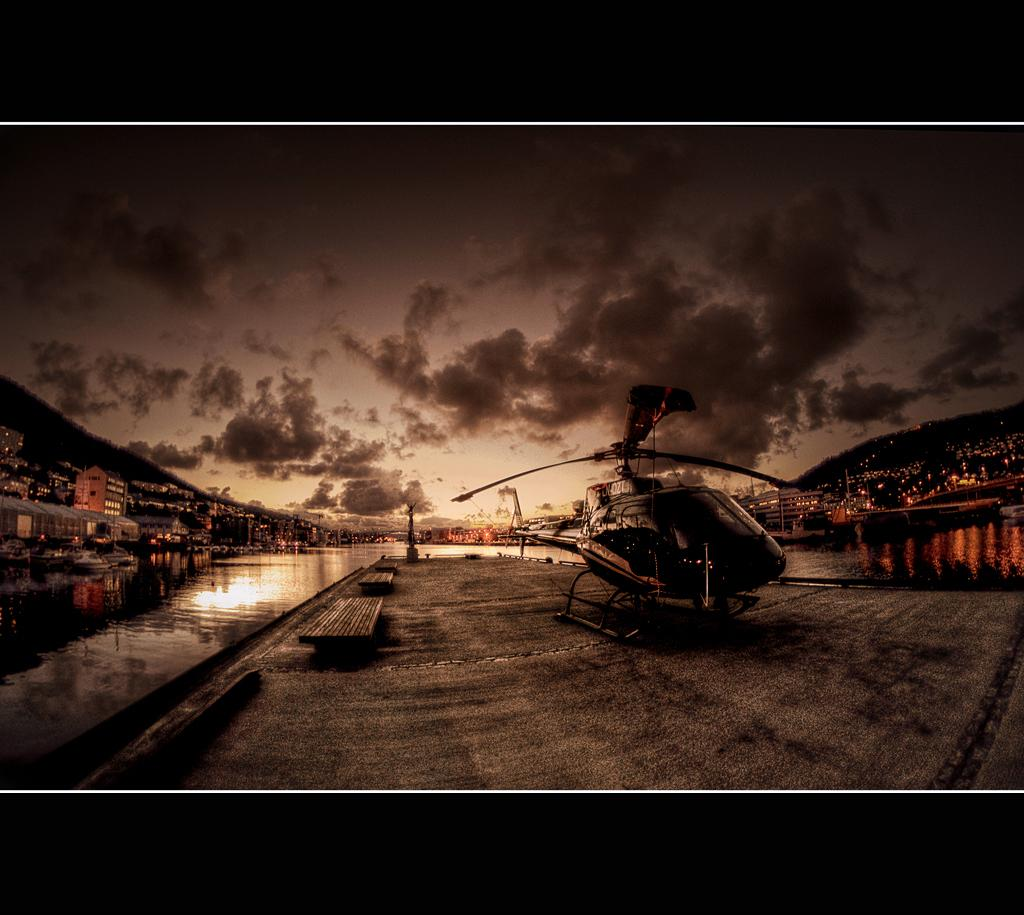What type of vehicle is present in the image? There is a helicopter in the image. What type of seating can be seen in the image? There are benches in the image. What type of structures are visible in the image? There are houses in the image. What type of natural features can be seen in the image? There are mountains and water visible in the image. What part of the natural environment is visible in the image? The sky is visible in the image. What is the color of the image's borders? The borders of the image are black in color. What type of list can be seen on the helicopter in the image? There is no list present on the helicopter in the image. What type of pets are visible in the image? There are no pets visible in the image. 